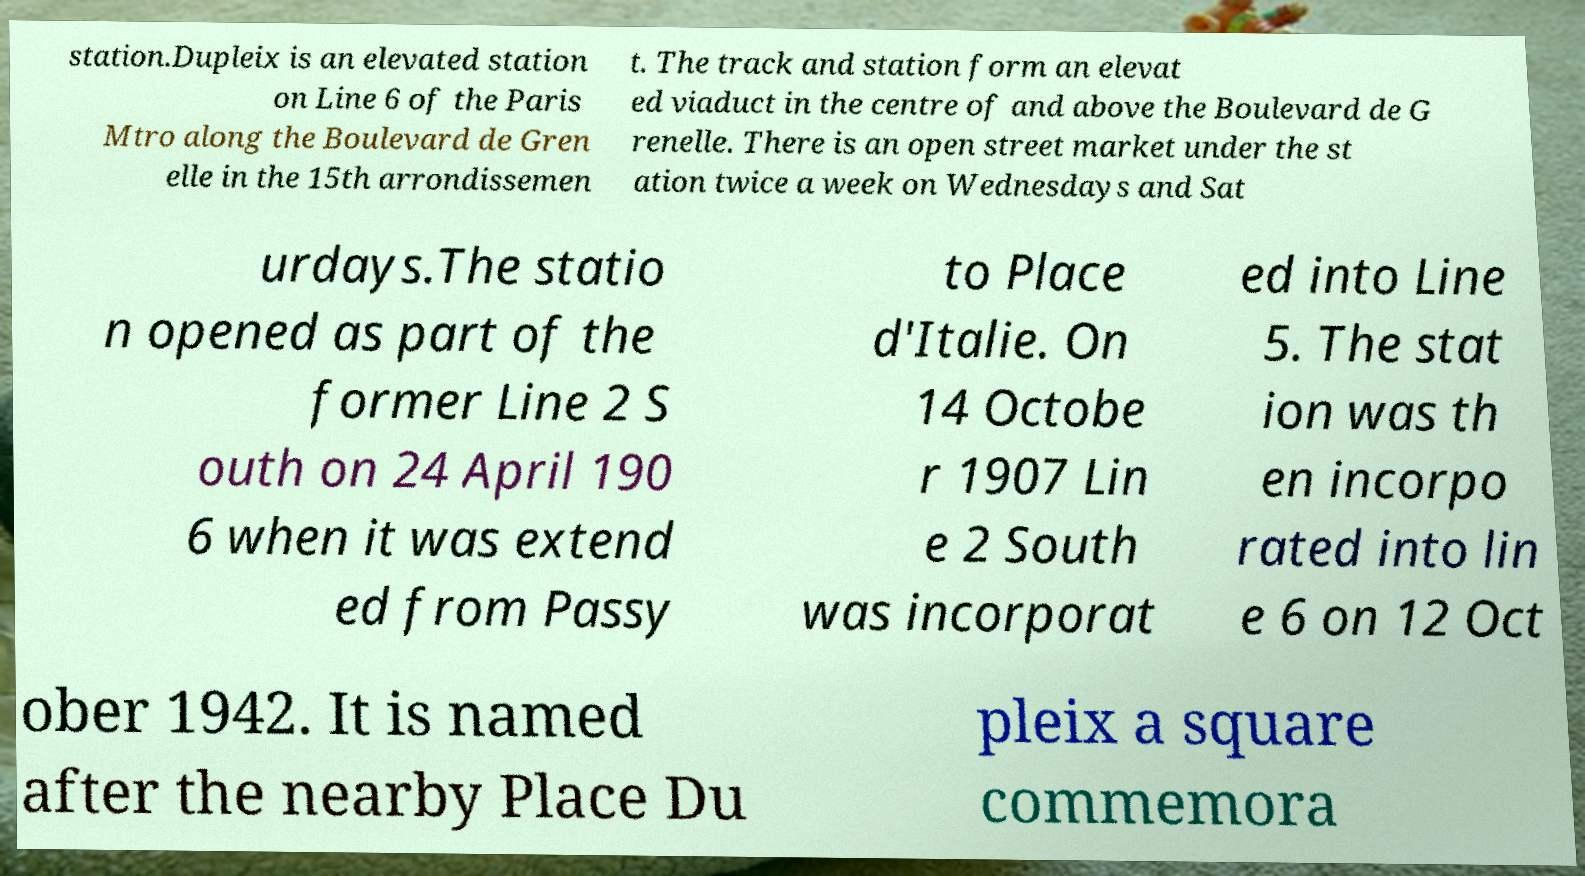Please read and relay the text visible in this image. What does it say? station.Dupleix is an elevated station on Line 6 of the Paris Mtro along the Boulevard de Gren elle in the 15th arrondissemen t. The track and station form an elevat ed viaduct in the centre of and above the Boulevard de G renelle. There is an open street market under the st ation twice a week on Wednesdays and Sat urdays.The statio n opened as part of the former Line 2 S outh on 24 April 190 6 when it was extend ed from Passy to Place d'Italie. On 14 Octobe r 1907 Lin e 2 South was incorporat ed into Line 5. The stat ion was th en incorpo rated into lin e 6 on 12 Oct ober 1942. It is named after the nearby Place Du pleix a square commemora 